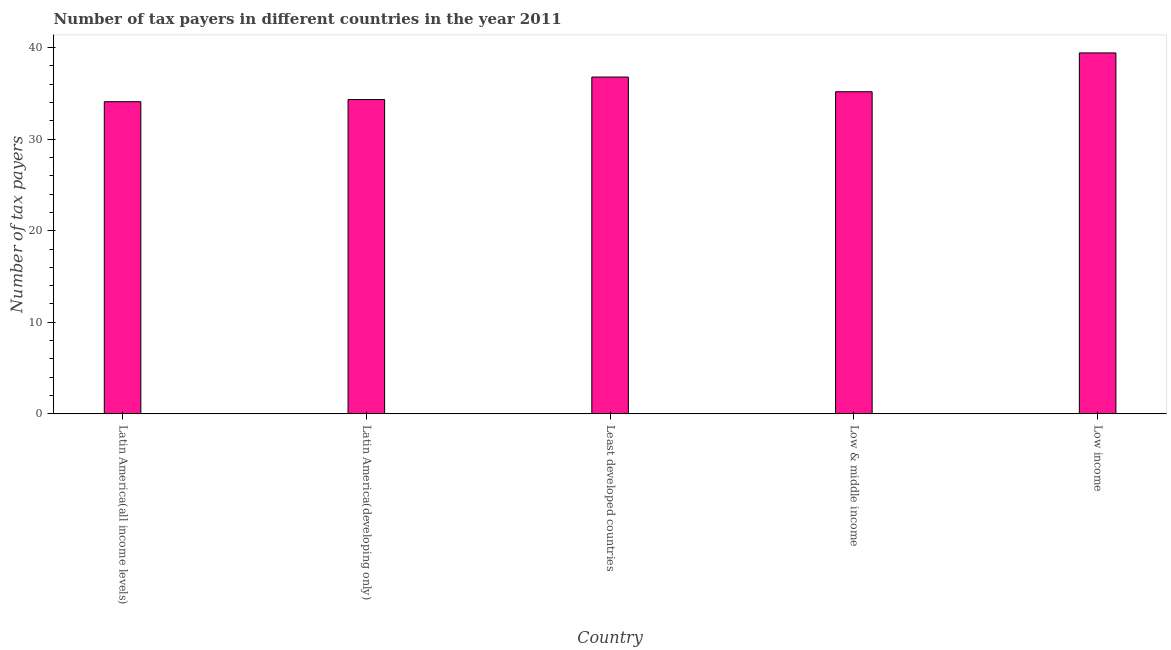What is the title of the graph?
Give a very brief answer. Number of tax payers in different countries in the year 2011. What is the label or title of the Y-axis?
Offer a terse response. Number of tax payers. What is the number of tax payers in Latin America(all income levels)?
Offer a very short reply. 34.1. Across all countries, what is the maximum number of tax payers?
Make the answer very short. 39.43. Across all countries, what is the minimum number of tax payers?
Keep it short and to the point. 34.1. In which country was the number of tax payers minimum?
Offer a very short reply. Latin America(all income levels). What is the sum of the number of tax payers?
Your response must be concise. 179.84. What is the difference between the number of tax payers in Low & middle income and Low income?
Ensure brevity in your answer.  -4.24. What is the average number of tax payers per country?
Give a very brief answer. 35.97. What is the median number of tax payers?
Provide a succinct answer. 35.19. What is the ratio of the number of tax payers in Low & middle income to that in Low income?
Provide a succinct answer. 0.89. What is the difference between the highest and the second highest number of tax payers?
Provide a succinct answer. 2.64. What is the difference between the highest and the lowest number of tax payers?
Make the answer very short. 5.33. In how many countries, is the number of tax payers greater than the average number of tax payers taken over all countries?
Your answer should be compact. 2. How many bars are there?
Your response must be concise. 5. Are all the bars in the graph horizontal?
Provide a succinct answer. No. How many countries are there in the graph?
Your answer should be very brief. 5. What is the Number of tax payers in Latin America(all income levels)?
Provide a short and direct response. 34.1. What is the Number of tax payers of Latin America(developing only)?
Your answer should be compact. 34.33. What is the Number of tax payers of Least developed countries?
Offer a very short reply. 36.79. What is the Number of tax payers in Low & middle income?
Make the answer very short. 35.19. What is the Number of tax payers of Low income?
Offer a very short reply. 39.43. What is the difference between the Number of tax payers in Latin America(all income levels) and Latin America(developing only)?
Ensure brevity in your answer.  -0.24. What is the difference between the Number of tax payers in Latin America(all income levels) and Least developed countries?
Ensure brevity in your answer.  -2.69. What is the difference between the Number of tax payers in Latin America(all income levels) and Low & middle income?
Provide a succinct answer. -1.09. What is the difference between the Number of tax payers in Latin America(all income levels) and Low income?
Provide a succinct answer. -5.33. What is the difference between the Number of tax payers in Latin America(developing only) and Least developed countries?
Offer a terse response. -2.46. What is the difference between the Number of tax payers in Latin America(developing only) and Low & middle income?
Provide a succinct answer. -0.85. What is the difference between the Number of tax payers in Latin America(developing only) and Low income?
Provide a succinct answer. -5.1. What is the difference between the Number of tax payers in Least developed countries and Low & middle income?
Provide a short and direct response. 1.6. What is the difference between the Number of tax payers in Least developed countries and Low income?
Your response must be concise. -2.64. What is the difference between the Number of tax payers in Low & middle income and Low income?
Your response must be concise. -4.24. What is the ratio of the Number of tax payers in Latin America(all income levels) to that in Latin America(developing only)?
Your response must be concise. 0.99. What is the ratio of the Number of tax payers in Latin America(all income levels) to that in Least developed countries?
Make the answer very short. 0.93. What is the ratio of the Number of tax payers in Latin America(all income levels) to that in Low & middle income?
Your answer should be compact. 0.97. What is the ratio of the Number of tax payers in Latin America(all income levels) to that in Low income?
Make the answer very short. 0.86. What is the ratio of the Number of tax payers in Latin America(developing only) to that in Least developed countries?
Make the answer very short. 0.93. What is the ratio of the Number of tax payers in Latin America(developing only) to that in Low income?
Your answer should be compact. 0.87. What is the ratio of the Number of tax payers in Least developed countries to that in Low & middle income?
Your answer should be compact. 1.05. What is the ratio of the Number of tax payers in Least developed countries to that in Low income?
Offer a terse response. 0.93. What is the ratio of the Number of tax payers in Low & middle income to that in Low income?
Your response must be concise. 0.89. 